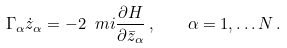<formula> <loc_0><loc_0><loc_500><loc_500>\Gamma _ { \alpha } \dot { z } _ { \alpha } = - 2 \ m i \frac { \partial H } { \partial \bar { z } _ { \alpha } } \, , \quad \alpha = 1 , \dots N \, .</formula> 